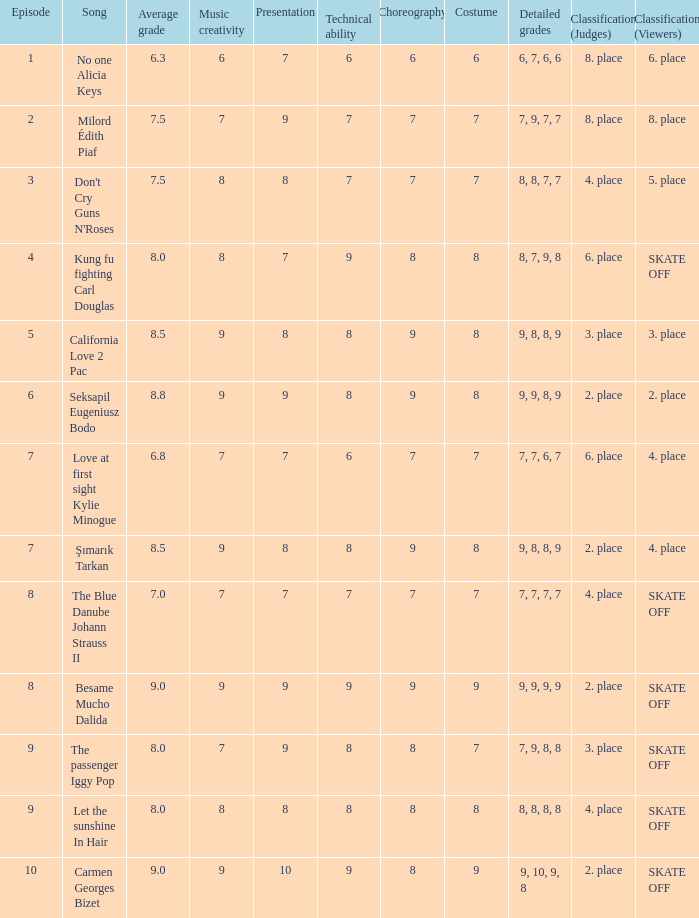Name the classification for 9, 9, 8, 9 2. place. 